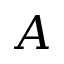<formula> <loc_0><loc_0><loc_500><loc_500>A</formula> 